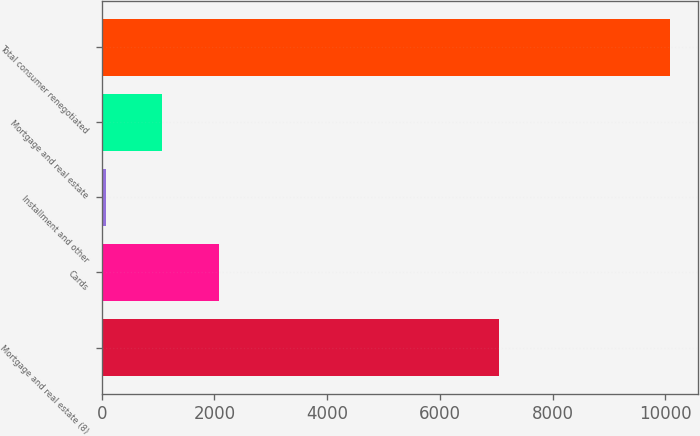Convert chart. <chart><loc_0><loc_0><loc_500><loc_500><bar_chart><fcel>Mortgage and real estate (8)<fcel>Cards<fcel>Installment and other<fcel>Mortgage and real estate<fcel>Total consumer renegotiated<nl><fcel>7058<fcel>2078.4<fcel>79<fcel>1078.7<fcel>10076<nl></chart> 